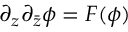<formula> <loc_0><loc_0><loc_500><loc_500>\partial _ { z } \partial _ { \bar { z } } \phi = F ( \phi )</formula> 